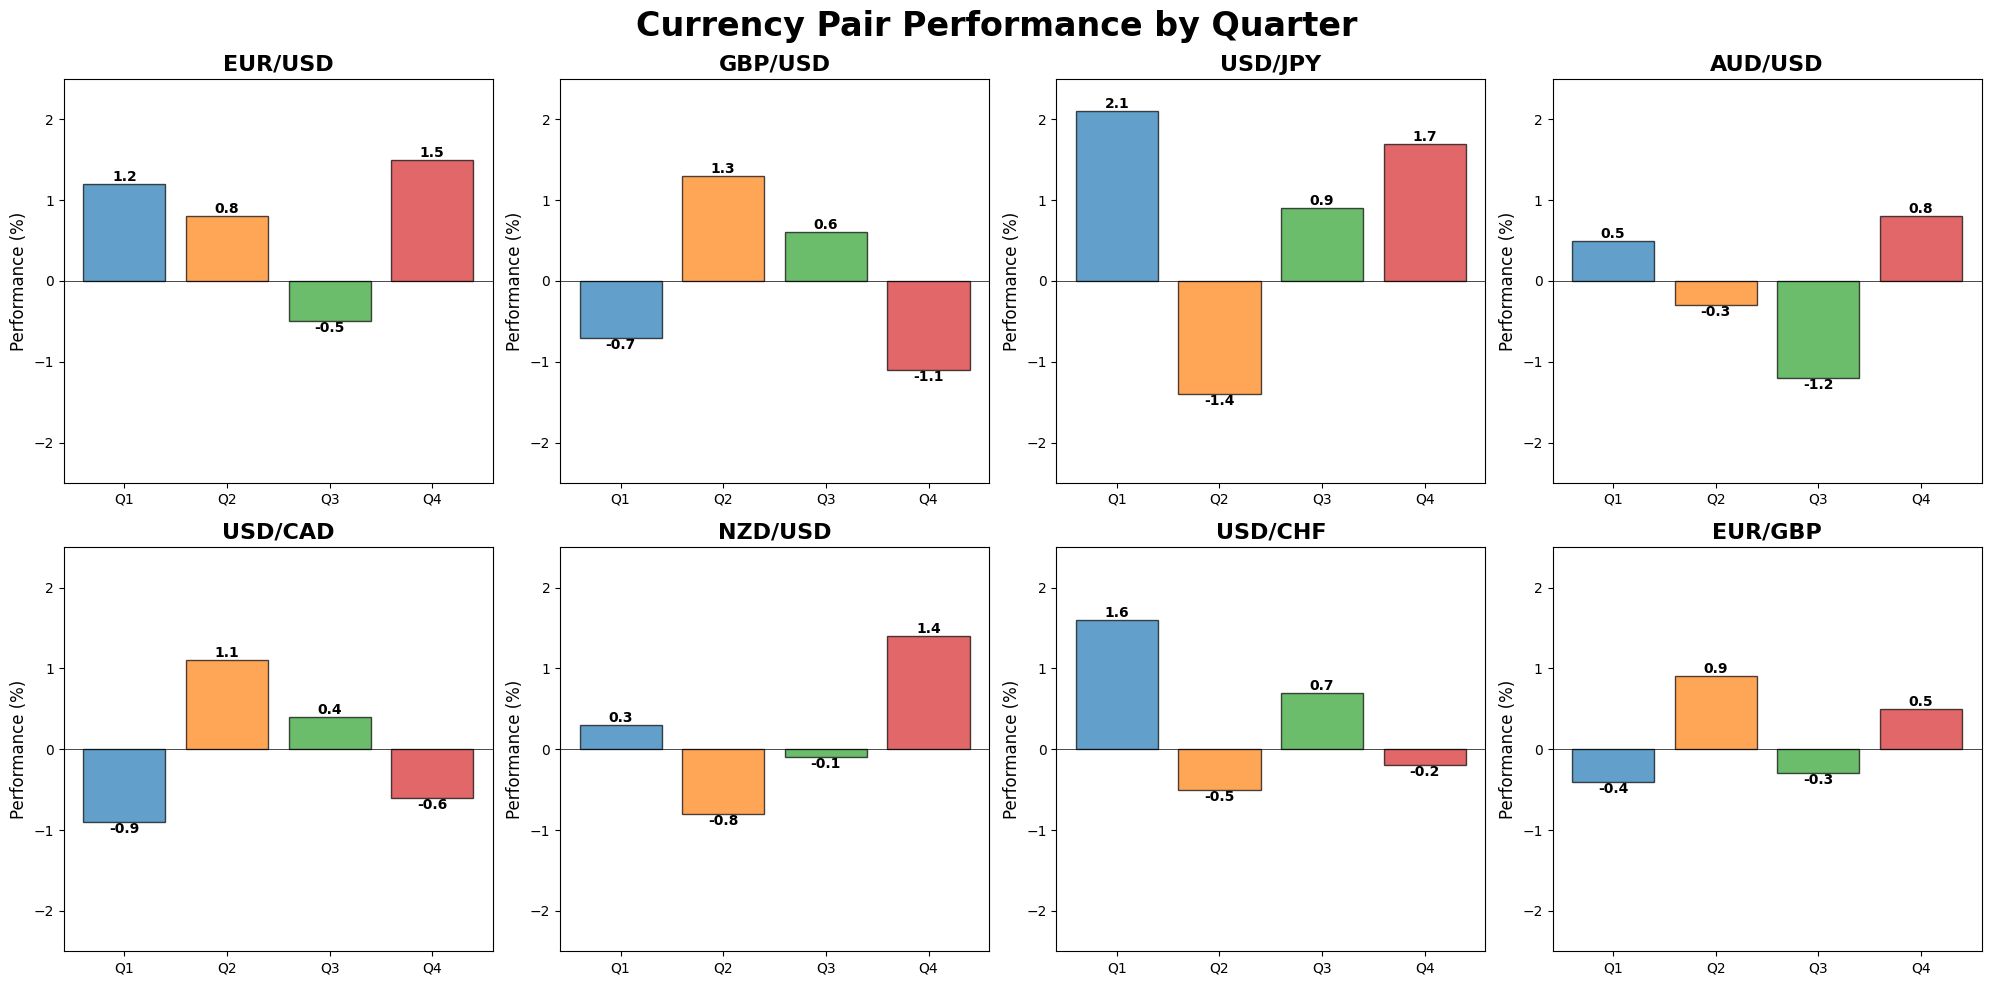Which currency pair had the highest performance in Q4? Look at the bar heights for Q4 across all subplots and identify the tallest bar. The tallest bar in Q4 is for USD/JPY with a value of 1.7.
Answer: USD/JPY Which quarter had the lowest performance for GBP/USD? Check the bar heights for GBP/USD across all quarters and find the lowest one. The lowest bar is in Q4 with a value of -1.1.
Answer: Q4 What is the difference in performance between Q1 and Q2 for EUR/USD? Subtract the performance value in Q2 from the value in Q1 for EUR/USD. Q1 is 1.2 and Q2 is 0.8, so the difference is 1.2 - 0.8 = 0.4.
Answer: 0.4 Which currency pair showed a negative performance in Q2? Identify bars below the axis line in Q2 across all subplots. The bars for USD/JPY, AUD/USD, NZD/USD, and USD/CHF are below the axis line in Q2 with values of -1.4, -0.3, -0.8, and -0.5 respectively.
Answer: USD/JPY, AUD/USD, NZD/USD, and USD/CHF For the USD/CAD currency pair, does the sum of Q2 and Q4 performances result in a net positive or negative? Add the performance values for Q2 and Q4 for USD/CAD. Q2 is 1.1 and Q4 is -0.6, so 1.1 - 0.6 = 0.5 which is positive.
Answer: Positive How many currency pairs had positive performance in both Q3 and Q1? Check which subplots have bars above the axis line in both Q3 and Q1. EUR/USD, USD/JPY, and USD/CHF have positive performances in both Q3 and Q1.
Answer: 3 currency pairs Which quarter had the overall best average performance across all currency pairs? Calculate the average performance for each quarter by summing the values of each quarter across all currency pairs, then dividing by the number of currency pairs (8). Q1: (1.2 - 0.7 + 2.1 + 0.5 - 0.9 + 0.3 + 1.6 - 0.4)/8 = 0.4625, Q2: (0.8 + 1.3 - 1.4 - 0.3 + 1.1 - 0.8 - 0.5 + 0.9)/8 = 0.1375, Q3: (-0.5 + 0.6 + 0.9 - 1.2 + 0.4 - 0.1 + 0.7 - 0.3)/8 = 0.0625, Q4: (1.5 - 1.1 + 1.7 + 0.8 - 0.6 + 1.4 - 0.2 + 0.5)/8 = 0.75. Q4 has the highest average of 0.75.
Answer: Q4 